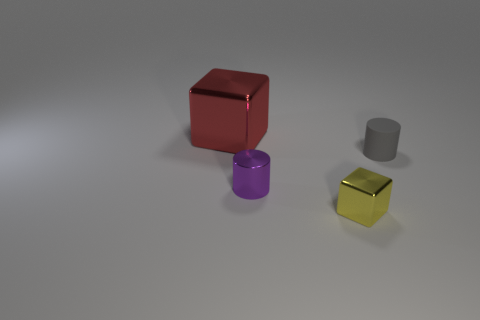Add 3 yellow shiny objects. How many objects exist? 7 Subtract all small purple shiny cylinders. Subtract all small purple things. How many objects are left? 2 Add 2 big red things. How many big red things are left? 3 Add 1 tiny green metal cubes. How many tiny green metal cubes exist? 1 Subtract 0 green cubes. How many objects are left? 4 